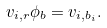Convert formula to latex. <formula><loc_0><loc_0><loc_500><loc_500>v _ { i , r } \phi _ { b } = v _ { i , b _ { i } } .</formula> 